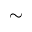<formula> <loc_0><loc_0><loc_500><loc_500>\sim</formula> 